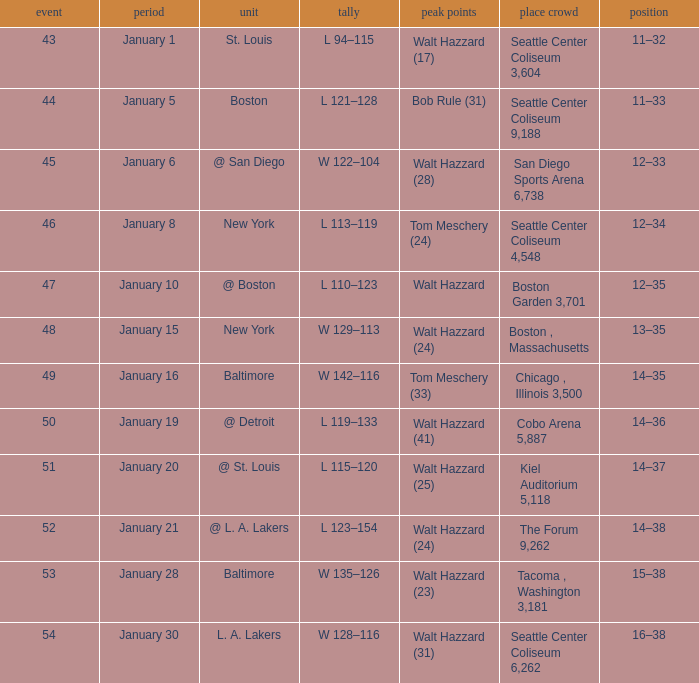What is the record for the St. Louis team? 11–32. 